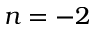<formula> <loc_0><loc_0><loc_500><loc_500>n = - 2</formula> 